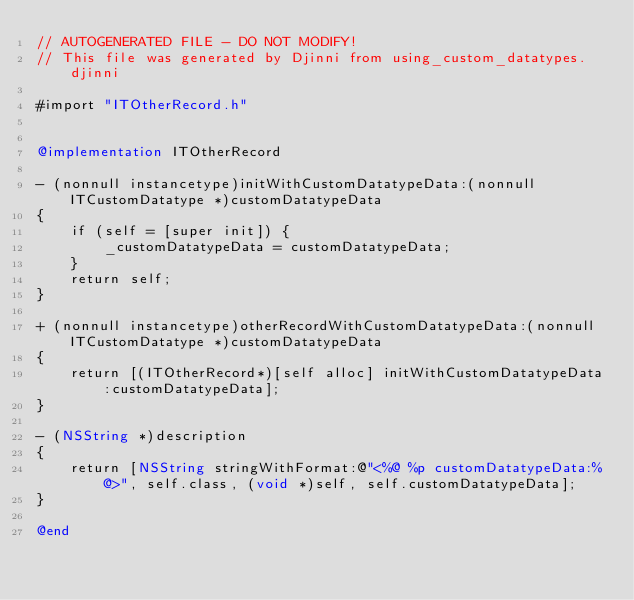Convert code to text. <code><loc_0><loc_0><loc_500><loc_500><_ObjectiveC_>// AUTOGENERATED FILE - DO NOT MODIFY!
// This file was generated by Djinni from using_custom_datatypes.djinni

#import "ITOtherRecord.h"


@implementation ITOtherRecord

- (nonnull instancetype)initWithCustomDatatypeData:(nonnull ITCustomDatatype *)customDatatypeData
{
    if (self = [super init]) {
        _customDatatypeData = customDatatypeData;
    }
    return self;
}

+ (nonnull instancetype)otherRecordWithCustomDatatypeData:(nonnull ITCustomDatatype *)customDatatypeData
{
    return [(ITOtherRecord*)[self alloc] initWithCustomDatatypeData:customDatatypeData];
}

- (NSString *)description
{
    return [NSString stringWithFormat:@"<%@ %p customDatatypeData:%@>", self.class, (void *)self, self.customDatatypeData];
}

@end
</code> 